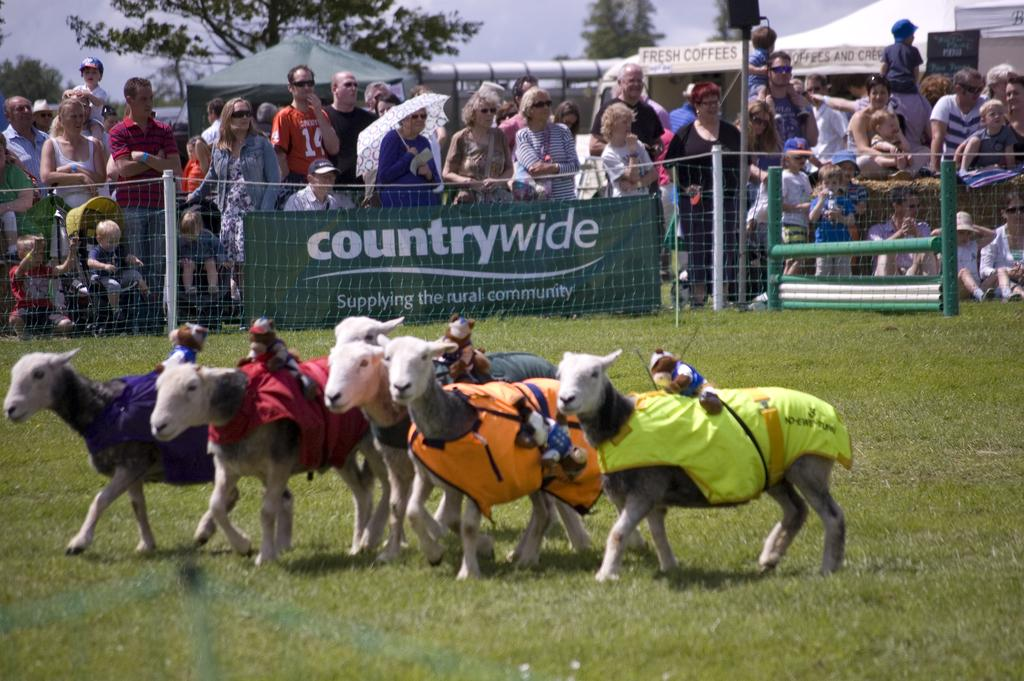What animals are present in the image? There is a herd of goats in the image. What are the goats wearing? The goats are wearing shirts in the image. What else can be seen on the goats? The goats have toys on them. Can you describe the people in the image? There is a group of people standing in the image. What structure can be seen in the image? There is a board in the image. What type of temporary shelter is visible in the image? There are tents in the image. What type of vegetation is present in the image? There are trees in the image. What part of the natural environment is visible in the image? The sky is visible in the image. What type of tin is being used by the authority in the image? There is no tin or authority present in the image. How is the aunt interacting with the goats in the image? There is no aunt present in the image. 